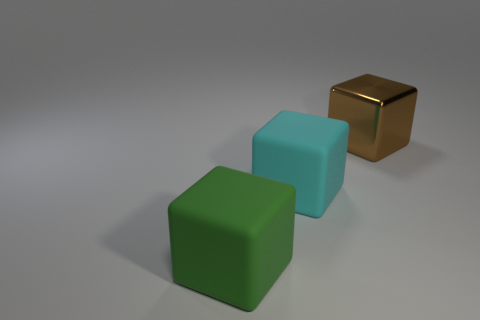Add 2 purple things. How many objects exist? 5 Subtract all green objects. Subtract all large green blocks. How many objects are left? 1 Add 1 large cyan rubber cubes. How many large cyan rubber cubes are left? 2 Add 3 brown shiny blocks. How many brown shiny blocks exist? 4 Subtract 1 cyan blocks. How many objects are left? 2 